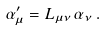<formula> <loc_0><loc_0><loc_500><loc_500>\alpha ^ { \prime } _ { \mu } = L _ { \mu \nu } \, \alpha _ { \nu } \, .</formula> 